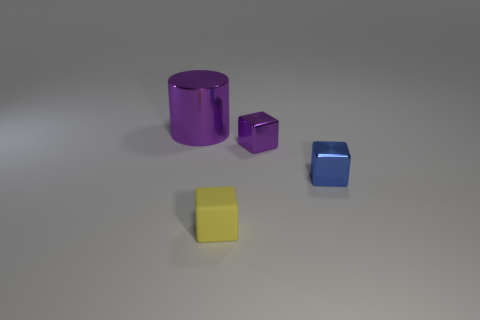What shape is the thing that is both left of the small purple shiny block and in front of the metal cylinder?
Provide a short and direct response. Cube. Are there more big blue metal spheres than small matte objects?
Make the answer very short. No. What is the material of the big object?
Offer a terse response. Metal. Is there any other thing that has the same size as the cylinder?
Your response must be concise. No. There is a object that is in front of the blue shiny cube; is there a small rubber cube that is in front of it?
Ensure brevity in your answer.  No. What number of other objects are the same shape as the big thing?
Give a very brief answer. 0. Is the number of purple things that are right of the big purple cylinder greater than the number of large things that are in front of the small purple thing?
Give a very brief answer. Yes. There is a purple shiny thing left of the tiny yellow cube; does it have the same size as the purple metal thing in front of the big metal thing?
Make the answer very short. No. What is the shape of the tiny yellow matte thing?
Give a very brief answer. Cube. There is a cube that is the same color as the cylinder; what is its size?
Provide a succinct answer. Small. 